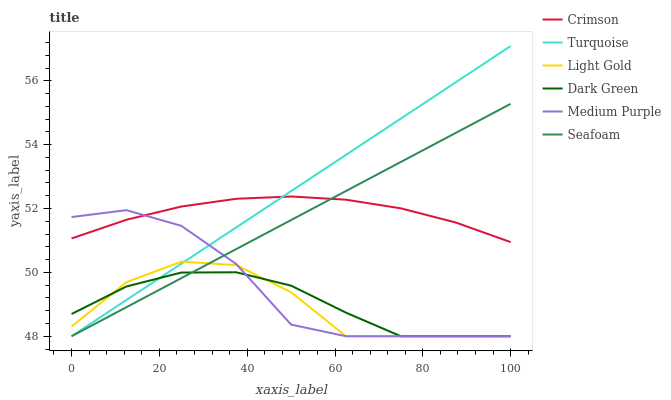Does Light Gold have the minimum area under the curve?
Answer yes or no. Yes. Does Turquoise have the maximum area under the curve?
Answer yes or no. Yes. Does Seafoam have the minimum area under the curve?
Answer yes or no. No. Does Seafoam have the maximum area under the curve?
Answer yes or no. No. Is Turquoise the smoothest?
Answer yes or no. Yes. Is Light Gold the roughest?
Answer yes or no. Yes. Is Seafoam the smoothest?
Answer yes or no. No. Is Seafoam the roughest?
Answer yes or no. No. Does Crimson have the lowest value?
Answer yes or no. No. Does Turquoise have the highest value?
Answer yes or no. Yes. Does Seafoam have the highest value?
Answer yes or no. No. Is Dark Green less than Crimson?
Answer yes or no. Yes. Is Crimson greater than Light Gold?
Answer yes or no. Yes. Does Seafoam intersect Dark Green?
Answer yes or no. Yes. Is Seafoam less than Dark Green?
Answer yes or no. No. Is Seafoam greater than Dark Green?
Answer yes or no. No. Does Dark Green intersect Crimson?
Answer yes or no. No. 